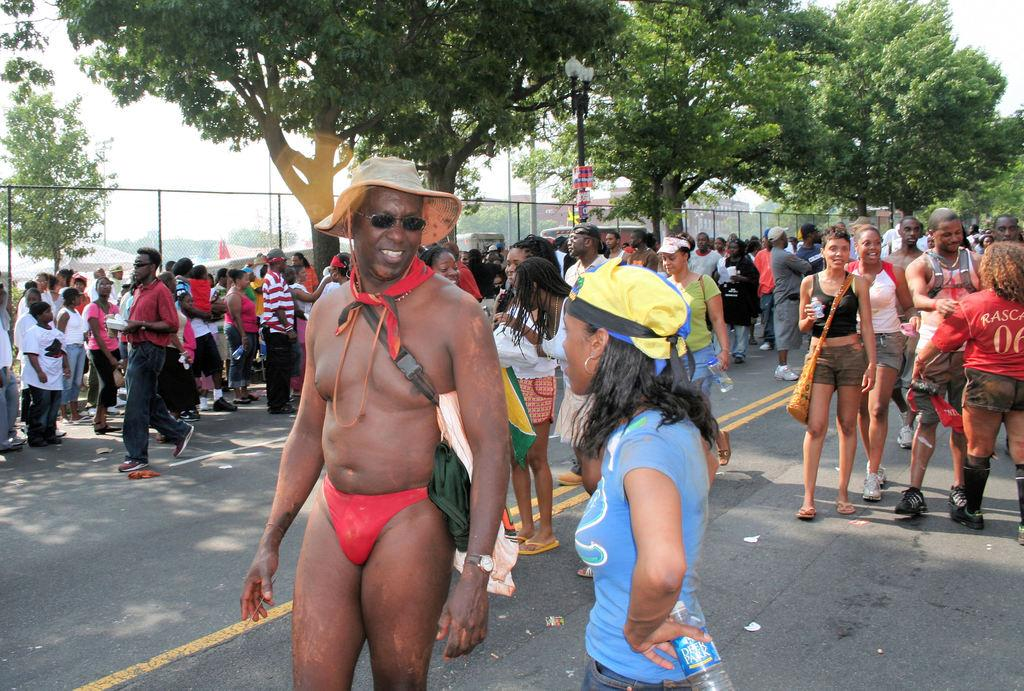What is happening on the road in the image? There are many persons on the road in the image. What can be seen in the background of the image? There are trees and fencing in the background of the image. What is visible in the sky in the image? The sky is visible in the background of the image. What type of quartz can be seen in the hands of the persons on the road? There is no quartz present in the image; it only shows persons on the road and elements in the background. 